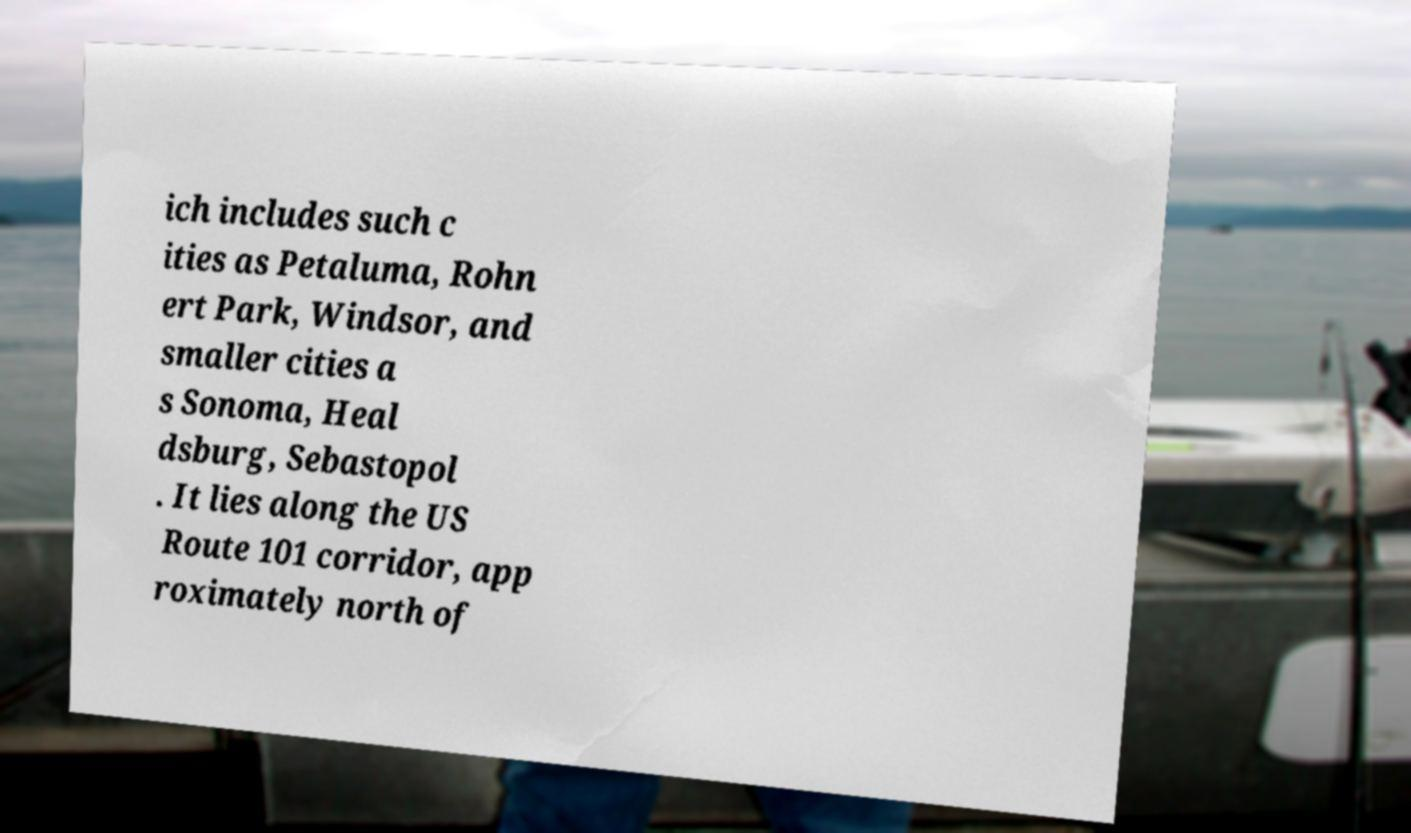Can you read and provide the text displayed in the image?This photo seems to have some interesting text. Can you extract and type it out for me? ich includes such c ities as Petaluma, Rohn ert Park, Windsor, and smaller cities a s Sonoma, Heal dsburg, Sebastopol . It lies along the US Route 101 corridor, app roximately north of 